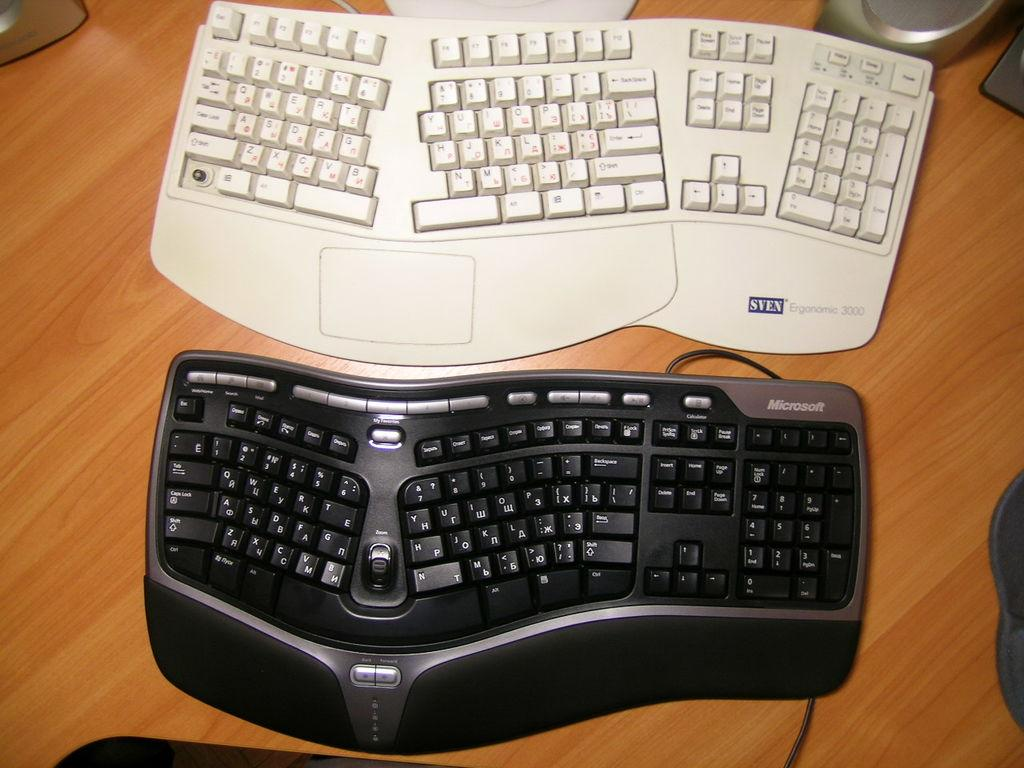<image>
Create a compact narrative representing the image presented. A white SVEN Ergonomic 3000 keyboard rests aside a black Microsoft keyboard. 